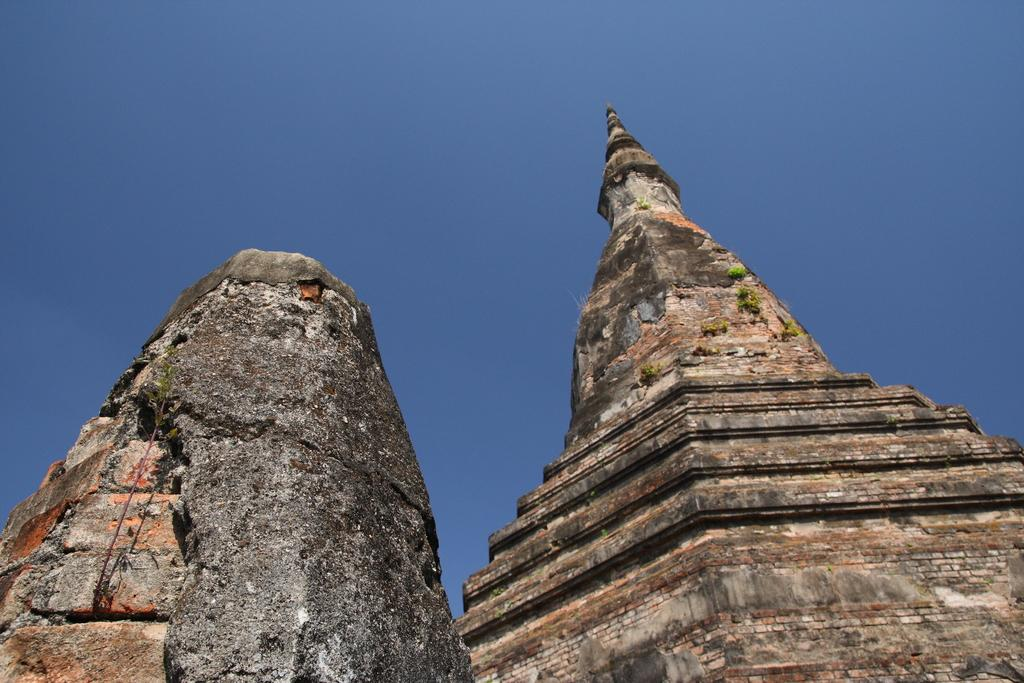What is the main structure in the image? There is a rock pyramid in the image. What can be seen on the ground in the image? The rock surface is visible in the image. What is visible in the background of the image? The sky is visible in the image. What is the color of the sky in the image? The color of the sky is blue. What type of string is being used for the voyage in the image? There is no string or voyage present in the image; it features a rock pyramid, rock surface, and blue sky. Can you tell me how many animals are in the zoo in the image? There is no zoo or animals present in the image. 